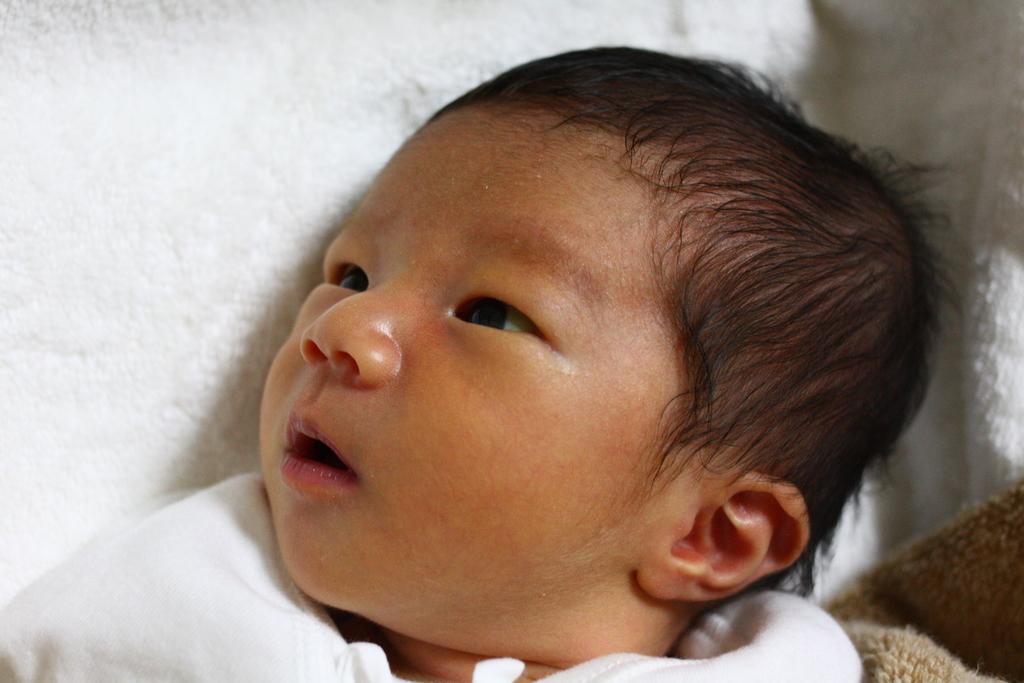Please provide a concise description of this image. In this picture we can see a baby lying on a white cloth. 